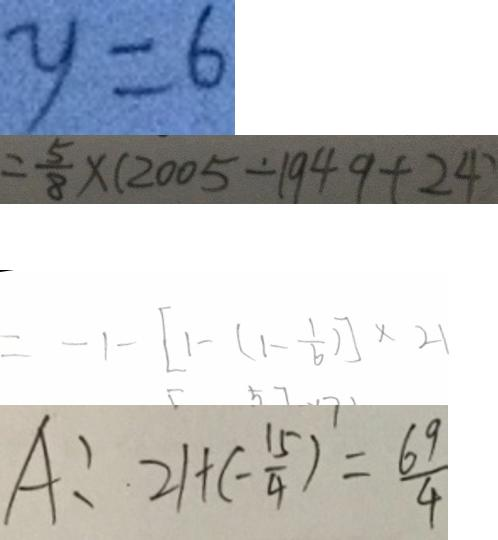Convert formula to latex. <formula><loc_0><loc_0><loc_500><loc_500>y = 6 
 = \frac { 5 } { 8 } \times ( 2 0 0 5 - 1 9 4 9 + 2 4 ) 
 = - 1 - [ 1 - ( 1 - \frac { 1 } { 6 } ) ] \times 2 1 
 A : 2 1 + ( - \frac { 1 5 } { 4 } ) = \frac { 6 9 } { 4 }</formula> 